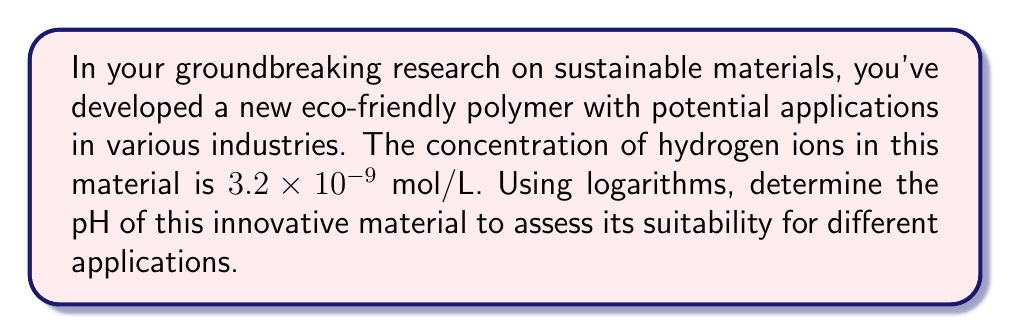Solve this math problem. To solve this problem, we'll use the definition of pH and apply logarithmic properties:

1) The pH is defined as the negative logarithm (base 10) of the hydrogen ion concentration:

   $$ pH = -\log_{10}[H^+] $$

2) We're given that $[H^+] = 3.2 \times 10^{-9}$ mol/L

3) Substituting this into the pH equation:

   $$ pH = -\log_{10}(3.2 \times 10^{-9}) $$

4) Using the logarithm product rule: $\log(a \times 10^n) = \log(a) + n$

   $$ pH = -(\log_{10}(3.2) + \log_{10}(10^{-9})) $$

5) Simplify:
   $$ pH = -(\log_{10}(3.2) - 9) $$

6) Calculate $\log_{10}(3.2)$ (use a calculator):
   $$ pH = -(0.5051 - 9) $$

7) Simplify:
   $$ pH = -0.5051 + 9 = 8.4949 $$

8) Round to 2 decimal places:
   $$ pH \approx 8.49 $$
Answer: $8.49$ 